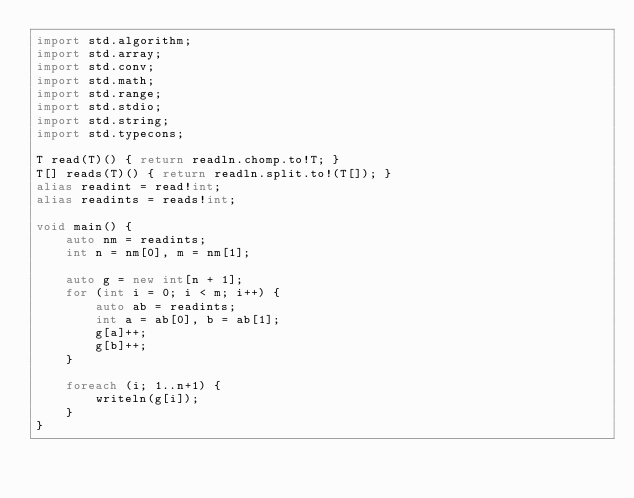<code> <loc_0><loc_0><loc_500><loc_500><_D_>import std.algorithm;
import std.array;
import std.conv;
import std.math;
import std.range;
import std.stdio;
import std.string;
import std.typecons;

T read(T)() { return readln.chomp.to!T; }
T[] reads(T)() { return readln.split.to!(T[]); }
alias readint = read!int;
alias readints = reads!int;

void main() {
    auto nm = readints;
    int n = nm[0], m = nm[1];

    auto g = new int[n + 1];
    for (int i = 0; i < m; i++) {
        auto ab = readints;
        int a = ab[0], b = ab[1];
        g[a]++;
        g[b]++;
    }

    foreach (i; 1..n+1) {
        writeln(g[i]);
    }
}
</code> 